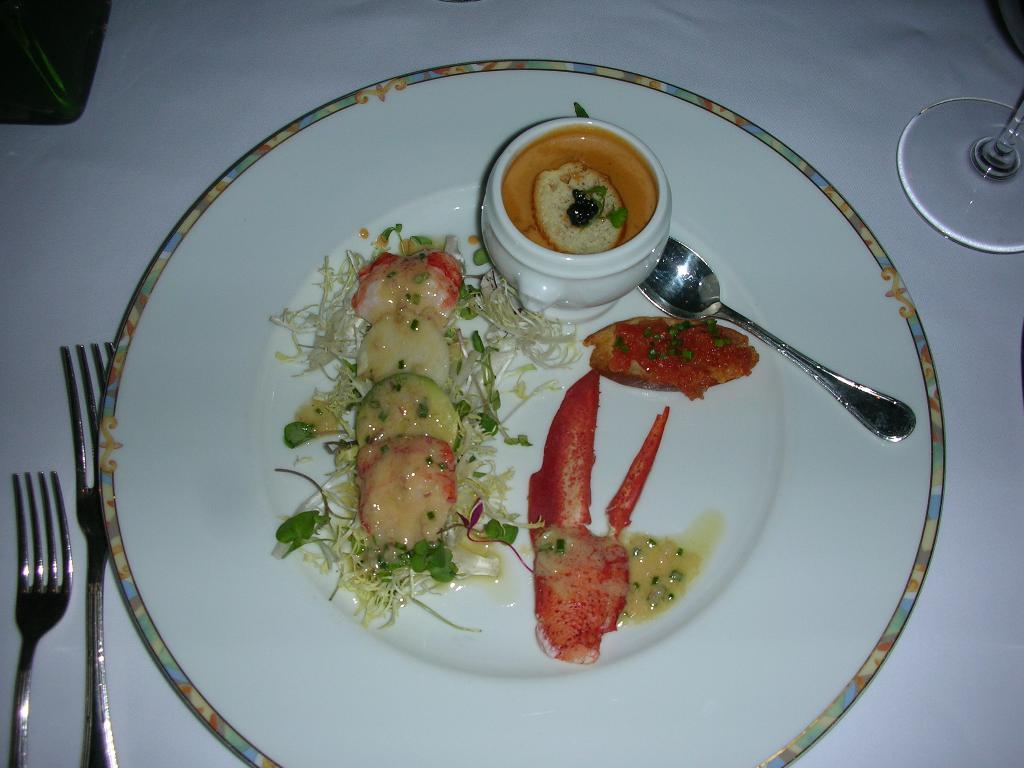What type of objects can be seen in the image? There are food items, a white color plate, a spoon, two forks, and a glass in the image. What is the color of the plate? The plate is white. What utensil is placed on the plate? A spoon is present on the plate. How many forks are visible in the image? There are two forks in the image. What is the other item made of glass in the image? There is a glass in the image. Where are all these items located? All these items are on the surface of a table. Can you tell me how the market is reflected in the glass in the image? There is no market present in the image, and therefore it cannot be reflected in the glass. What type of smile can be seen on the food items in the image? There are no faces or expressions on the food items in the image, so there is no smile to be seen. 